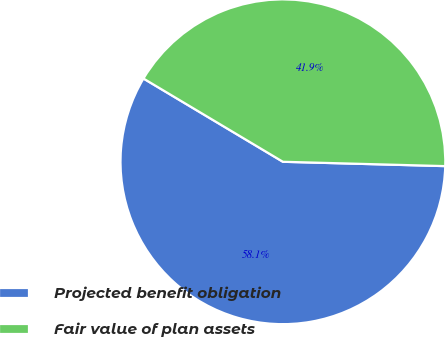Convert chart to OTSL. <chart><loc_0><loc_0><loc_500><loc_500><pie_chart><fcel>Projected benefit obligation<fcel>Fair value of plan assets<nl><fcel>58.14%<fcel>41.86%<nl></chart> 